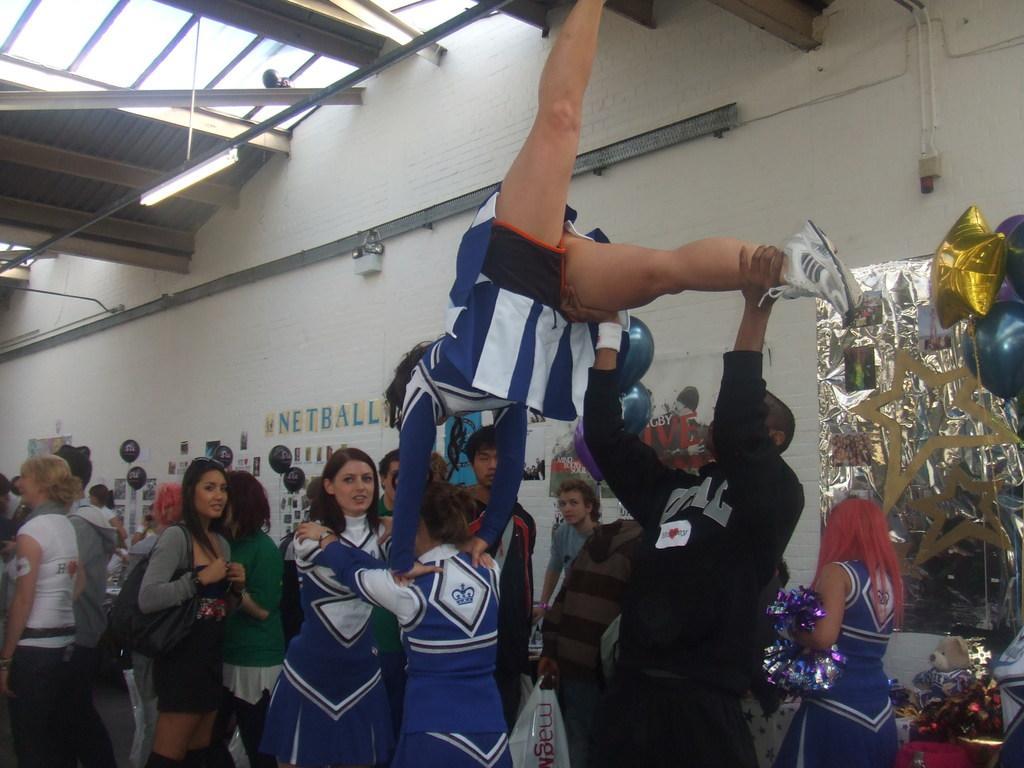Please provide a concise description of this image. In this image I can see group of people standing and one person is holding another person. I can see few colorful balloons and few stickers are attached to the wall. 